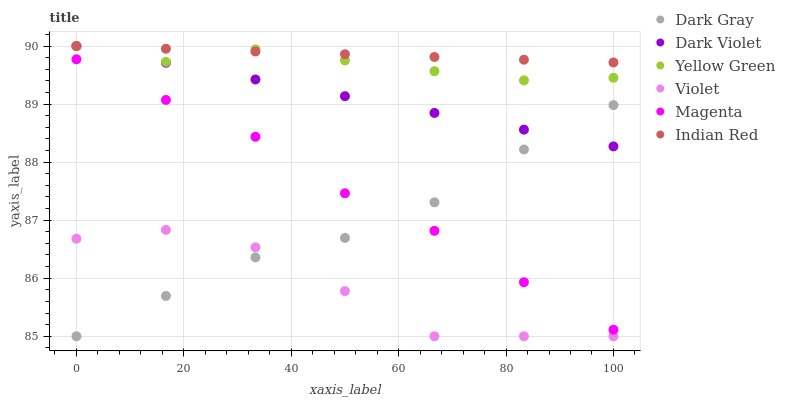Does Violet have the minimum area under the curve?
Answer yes or no. Yes. Does Indian Red have the maximum area under the curve?
Answer yes or no. Yes. Does Dark Violet have the minimum area under the curve?
Answer yes or no. No. Does Dark Violet have the maximum area under the curve?
Answer yes or no. No. Is Indian Red the smoothest?
Answer yes or no. Yes. Is Violet the roughest?
Answer yes or no. Yes. Is Dark Violet the smoothest?
Answer yes or no. No. Is Dark Violet the roughest?
Answer yes or no. No. Does Dark Gray have the lowest value?
Answer yes or no. Yes. Does Dark Violet have the lowest value?
Answer yes or no. No. Does Indian Red have the highest value?
Answer yes or no. Yes. Does Dark Gray have the highest value?
Answer yes or no. No. Is Violet less than Dark Violet?
Answer yes or no. Yes. Is Indian Red greater than Dark Gray?
Answer yes or no. Yes. Does Dark Violet intersect Yellow Green?
Answer yes or no. Yes. Is Dark Violet less than Yellow Green?
Answer yes or no. No. Is Dark Violet greater than Yellow Green?
Answer yes or no. No. Does Violet intersect Dark Violet?
Answer yes or no. No. 